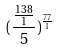Convert formula to latex. <formula><loc_0><loc_0><loc_500><loc_500>( \frac { \frac { 1 3 8 } { 1 } } { 5 } ) ^ { \frac { 7 7 } { 1 } }</formula> 